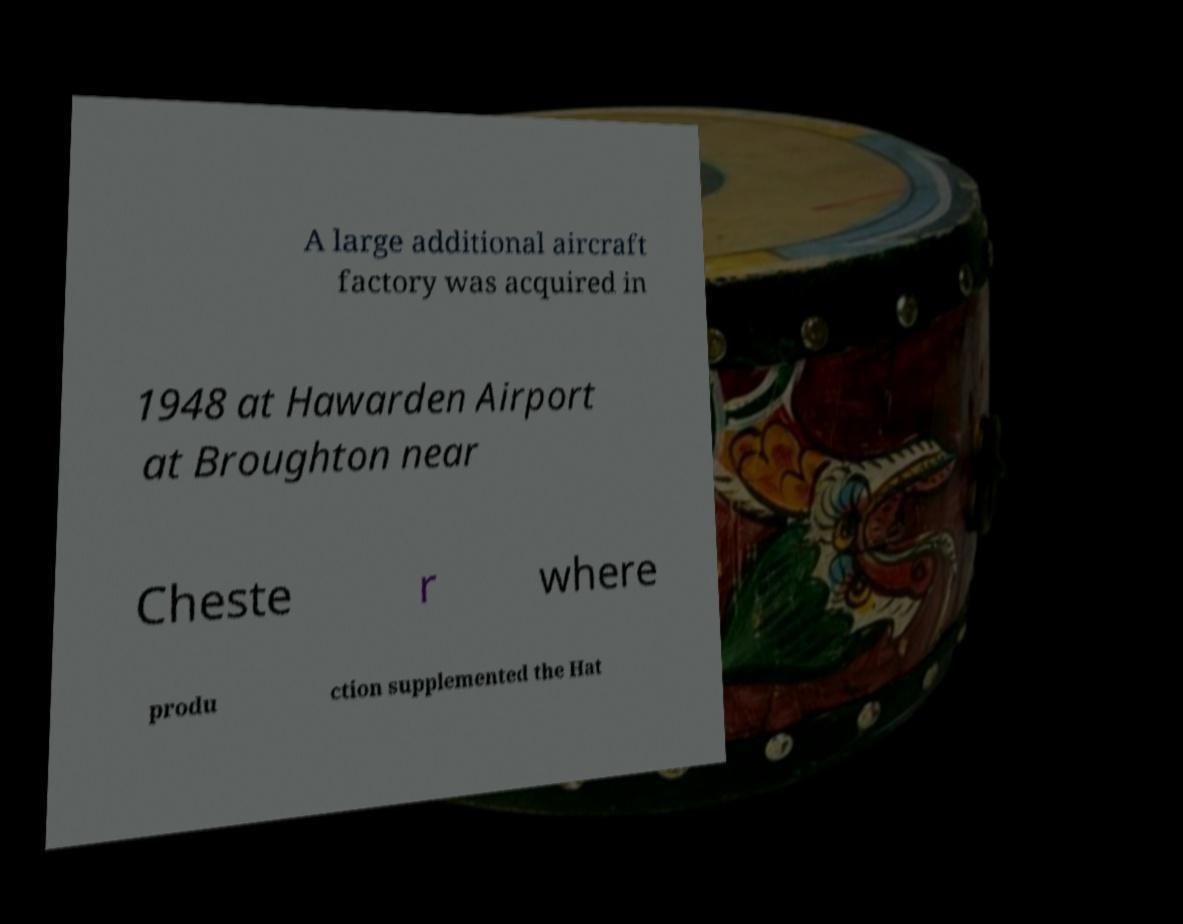Could you assist in decoding the text presented in this image and type it out clearly? A large additional aircraft factory was acquired in 1948 at Hawarden Airport at Broughton near Cheste r where produ ction supplemented the Hat 